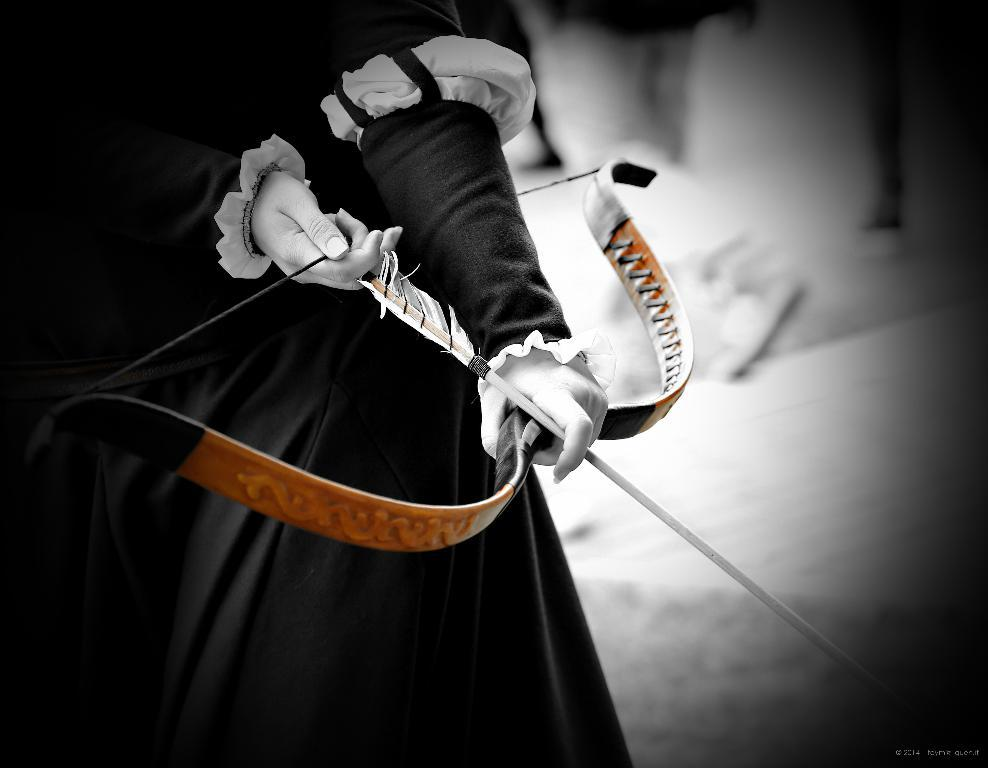Who is the main subject in the image? There is a lady in the image. Where is the lady positioned in the image? The lady is standing on the left side of the image. What is the lady holding in her hands? The lady is holding an arrow in her hands. What type of knee injury can be seen on the lady in the image? There is no indication of a knee injury in the image; the lady is standing and appears to be in good health. 